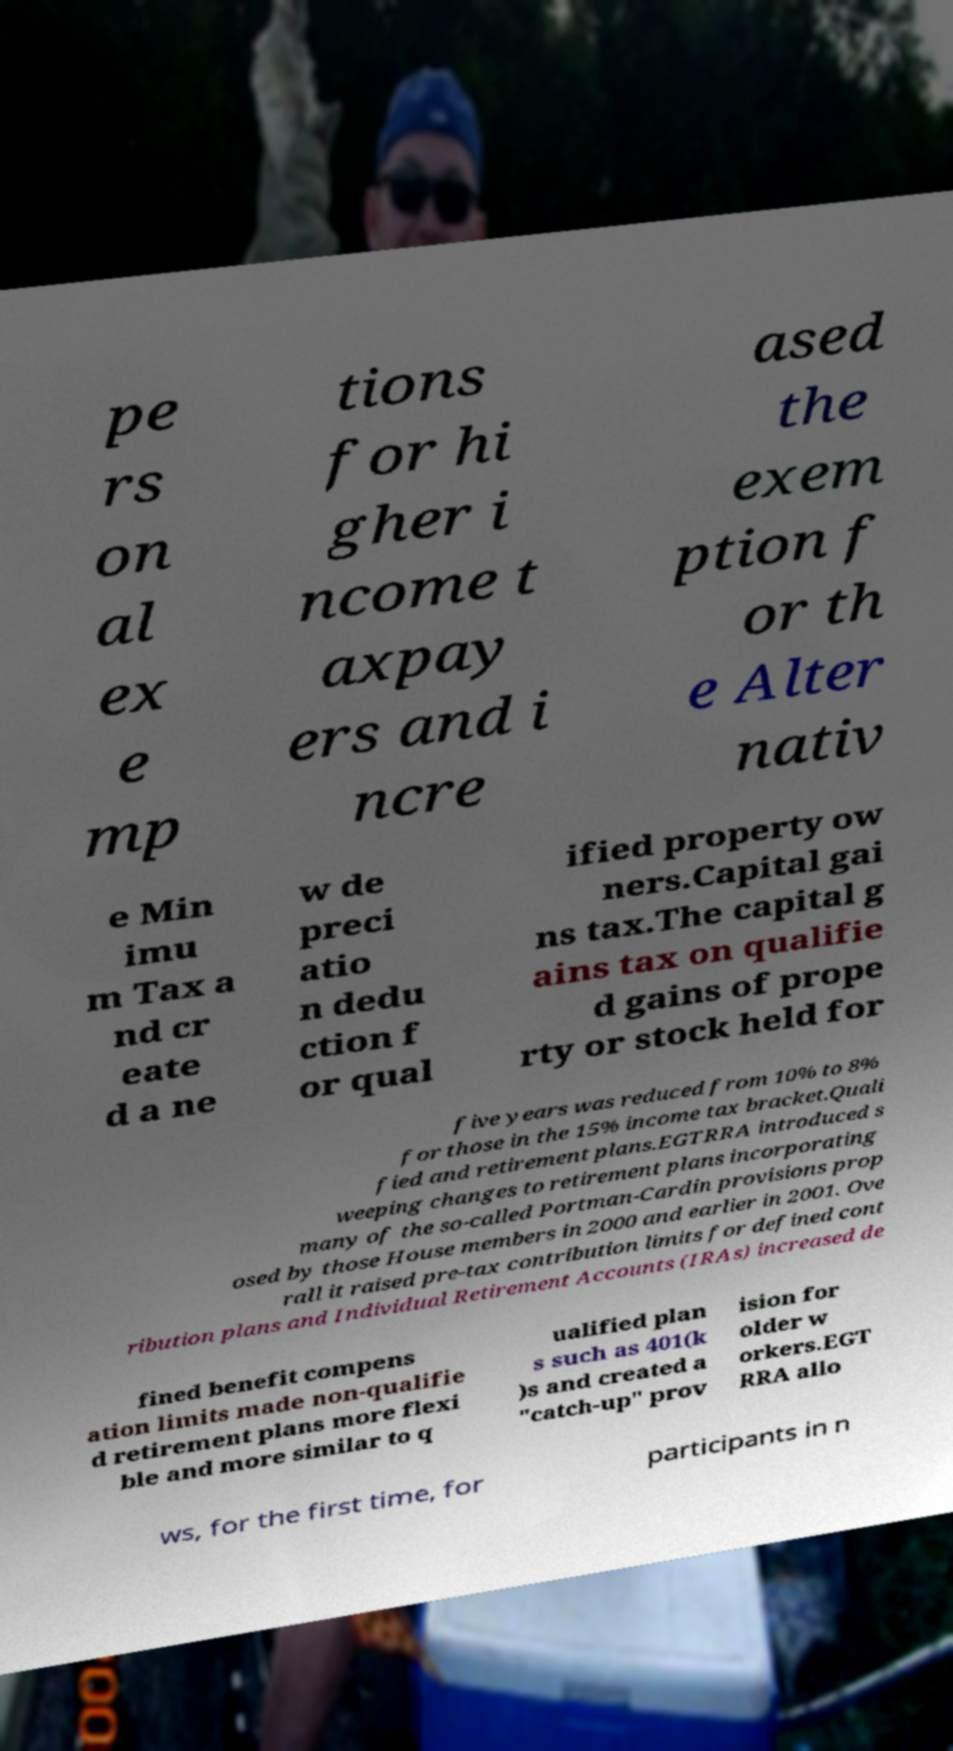Could you extract and type out the text from this image? pe rs on al ex e mp tions for hi gher i ncome t axpay ers and i ncre ased the exem ption f or th e Alter nativ e Min imu m Tax a nd cr eate d a ne w de preci atio n dedu ction f or qual ified property ow ners.Capital gai ns tax.The capital g ains tax on qualifie d gains of prope rty or stock held for five years was reduced from 10% to 8% for those in the 15% income tax bracket.Quali fied and retirement plans.EGTRRA introduced s weeping changes to retirement plans incorporating many of the so-called Portman-Cardin provisions prop osed by those House members in 2000 and earlier in 2001. Ove rall it raised pre-tax contribution limits for defined cont ribution plans and Individual Retirement Accounts (IRAs) increased de fined benefit compens ation limits made non-qualifie d retirement plans more flexi ble and more similar to q ualified plan s such as 401(k )s and created a "catch-up" prov ision for older w orkers.EGT RRA allo ws, for the first time, for participants in n 